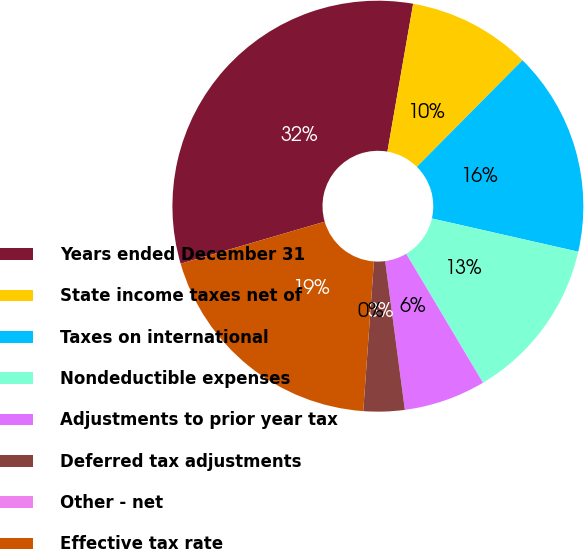Convert chart. <chart><loc_0><loc_0><loc_500><loc_500><pie_chart><fcel>Years ended December 31<fcel>State income taxes net of<fcel>Taxes on international<fcel>Nondeductible expenses<fcel>Adjustments to prior year tax<fcel>Deferred tax adjustments<fcel>Other - net<fcel>Effective tax rate<nl><fcel>32.26%<fcel>9.68%<fcel>16.13%<fcel>12.9%<fcel>6.45%<fcel>3.23%<fcel>0.0%<fcel>19.35%<nl></chart> 